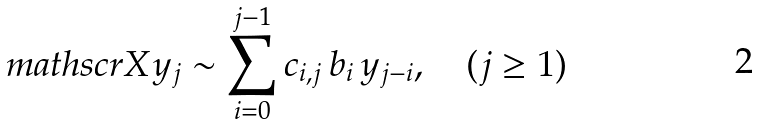Convert formula to latex. <formula><loc_0><loc_0><loc_500><loc_500>\ m a t h s c r { X } y _ { j } \sim \sum _ { i = 0 } ^ { j - 1 } c _ { i , j } \, b _ { i } \, y _ { j - i } , \quad ( j \geq 1 )</formula> 